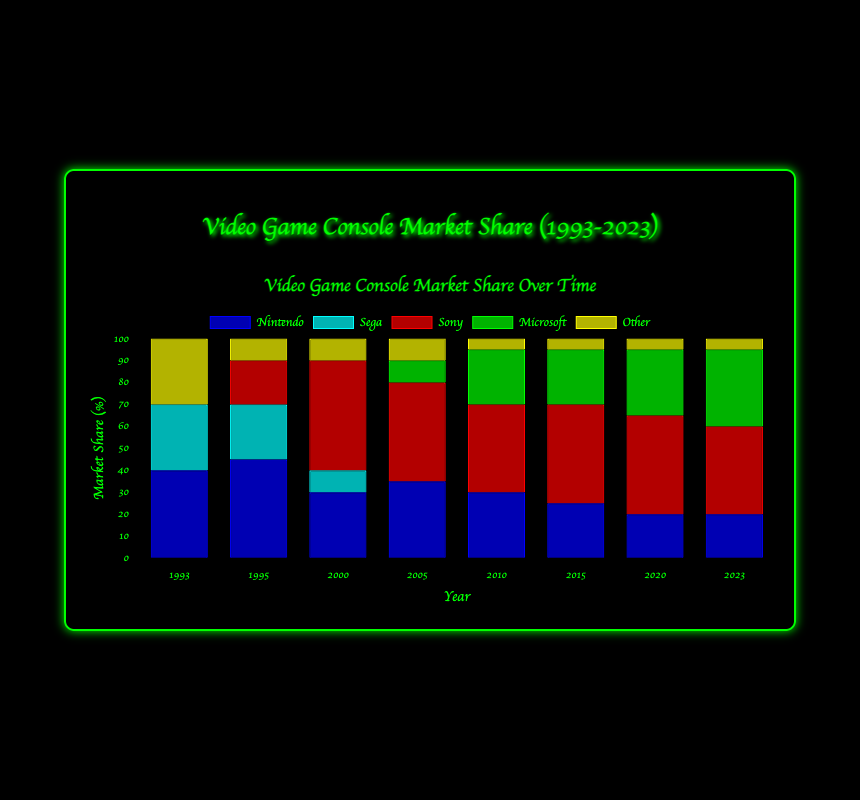Which company had the highest market share in 1993? Compare the heights of the bars for each company in the year 1993. Nintendo's bar is the tallest, indicating the highest market share.
Answer: Nintendo How did Sony's market share change from 2000 to 2020? Look at the height of the red bar (Sony) in 2000 and compare it to its height in 2020. In 2000, Sony had a 50% market share, which remained consistent at 45% in 2020.
Answer: Decreased by 5% In which year did Microsoft first appear in the market share data? Examine the years shown and identify the first year where the green bar (Microsoft) is present. Microsoft appears for the first time in 2005.
Answer: 2005 Between 2010 and 2015, which company saw the largest drop in market share? Compare the heights of the bars for each company between 2010 and 2015. Nintendo's bar drops from 30% to 25%, which is the largest decrease of 5%.
Answer: Nintendo What is the combined market share of Nintendo and Sega in 1995? Sum the market shares of Nintendo (45) and Sega (25) in 1995. The combined market share is 45 + 25 = 70%.
Answer: 70% Which company had a higher market share in 2023, Sony or Microsoft? Compare the heights of the red bar (Sony) and the green bar (Microsoft) in 2023. Sony has a market share of 40%, while Microsoft has a market share of 35%.
Answer: Sony How many different companies had a market share in 1993? Count the non-zero bars in 1993. The companies with non-zero market share are Nintendo, Sega, and Other, making it 3 companies.
Answer: 3 What is the total market share of 'Other' from 1993 to 2023? Sum the market shares of 'Other' for all the years: 30 (1993) + 10 (1995) + 10 (2000) + 10 (2005) + 5 (2010) + 5 (2015) + 5 (2020) + 5 (2023). The total is 80.
Answer: 80% How does Sega's market share change from 1993 to 2000? Look at the height of the cyan bar (Sega) in 1993 and compare it to its height in 2000. In 1993, Sega had a 30% market share which dropped to 10% by 2000.
Answer: Decreased by 20% What is the average market share of Nintendo from 2005 to 2023? Under the timeline from 2005 to 2023, the values for Nintendo are: 35%, 30%, 25%, 20%, 20%. The average is calculated as (35 + 30 + 25 + 20 + 20) / 5 = 26%.
Answer: 26% 